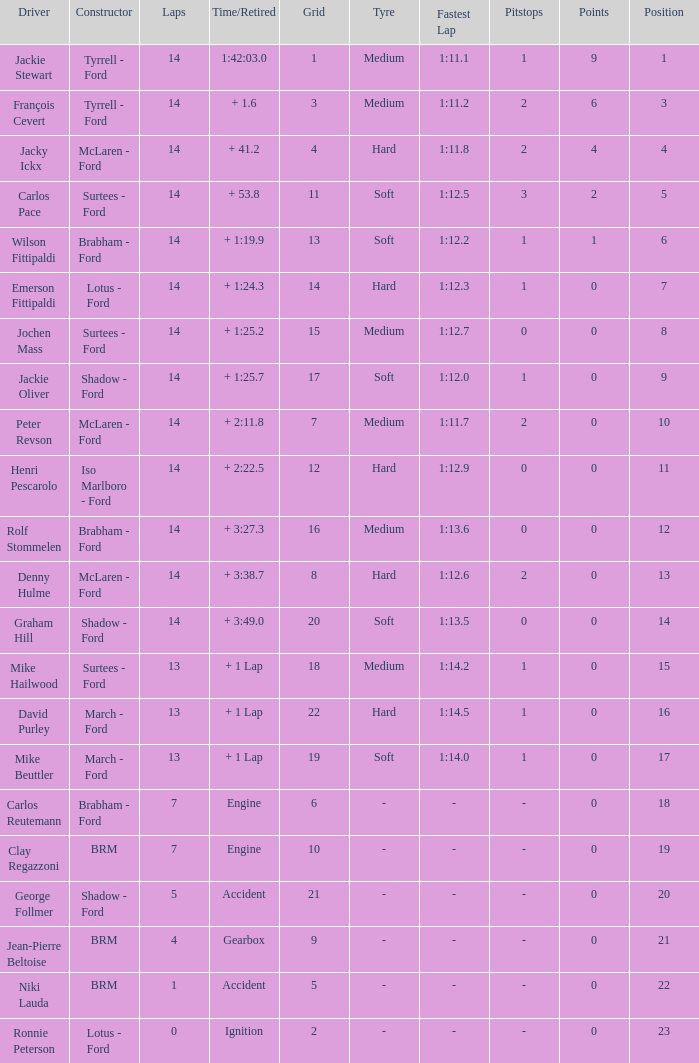What is the low lap total for henri pescarolo with a grad larger than 6? 14.0. 